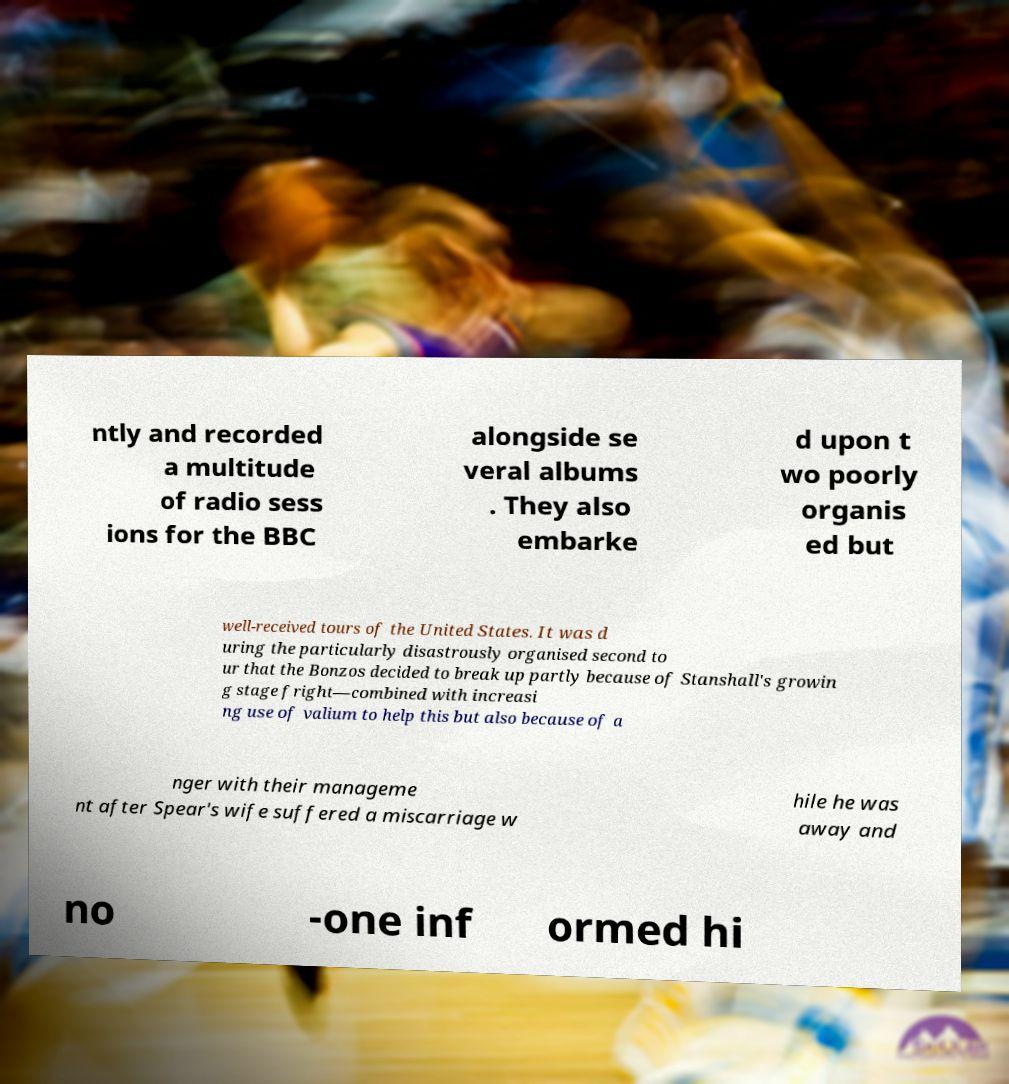I need the written content from this picture converted into text. Can you do that? ntly and recorded a multitude of radio sess ions for the BBC alongside se veral albums . They also embarke d upon t wo poorly organis ed but well-received tours of the United States. It was d uring the particularly disastrously organised second to ur that the Bonzos decided to break up partly because of Stanshall's growin g stage fright—combined with increasi ng use of valium to help this but also because of a nger with their manageme nt after Spear's wife suffered a miscarriage w hile he was away and no -one inf ormed hi 